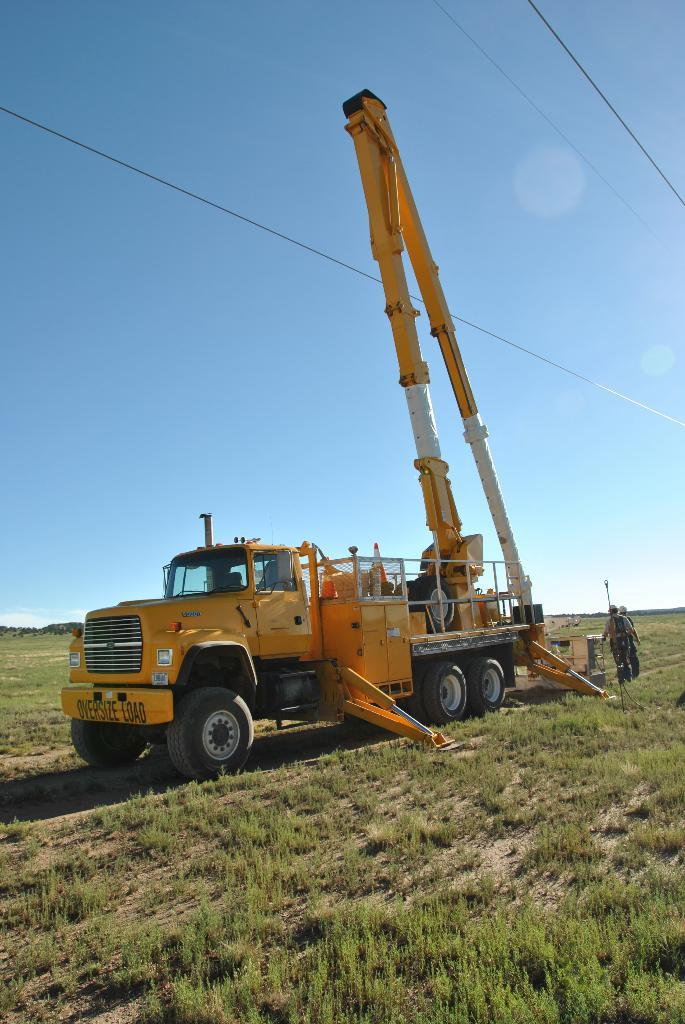What is the main subject of the picture? The main subject of the picture is a crane. Can you describe the appearance of the crane? The crane is yellow and white in color. What can be seen on the ground in the picture? There are people standing on the ground, and there is grass on the ground. What is the color of the sky in the picture? The sky is blue in the picture. What type of reaction does the crane have when presented with a riddle in the image? There is no riddle or reaction present in the image; it only features a yellow and white crane, people standing on the ground, grass, and a blue sky. 